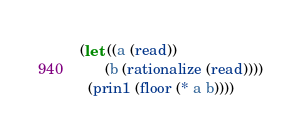Convert code to text. <code><loc_0><loc_0><loc_500><loc_500><_Lisp_>(let ((a (read))
      (b (rationalize (read))))
  (prin1 (floor (* a b))))</code> 